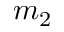Convert formula to latex. <formula><loc_0><loc_0><loc_500><loc_500>m _ { 2 }</formula> 